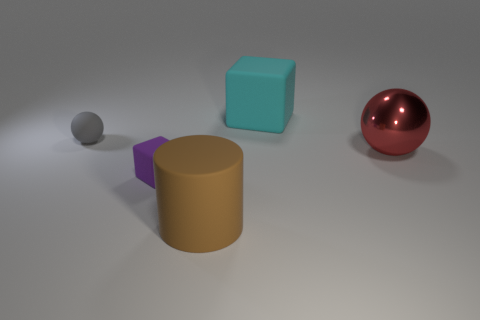There is a ball that is left of the tiny thing that is in front of the gray sphere that is left of the matte cylinder; what is it made of?
Provide a short and direct response. Rubber. There is a cyan thing that is made of the same material as the brown object; what shape is it?
Keep it short and to the point. Cube. Is there any other thing that is the same color as the big metal object?
Give a very brief answer. No. There is a matte cube left of the big thing in front of the large red metallic sphere; what number of small purple cubes are behind it?
Give a very brief answer. 0. How many red things are either shiny spheres or small balls?
Your response must be concise. 1. Do the brown thing and the rubber block that is in front of the gray rubber object have the same size?
Your response must be concise. No. What is the material of the other thing that is the same shape as the purple rubber object?
Keep it short and to the point. Rubber. What number of other objects are the same size as the red metal object?
Provide a succinct answer. 2. The small object that is behind the matte block that is left of the big object that is in front of the large shiny object is what shape?
Your response must be concise. Sphere. What is the shape of the thing that is behind the small purple object and in front of the gray rubber thing?
Provide a short and direct response. Sphere. 